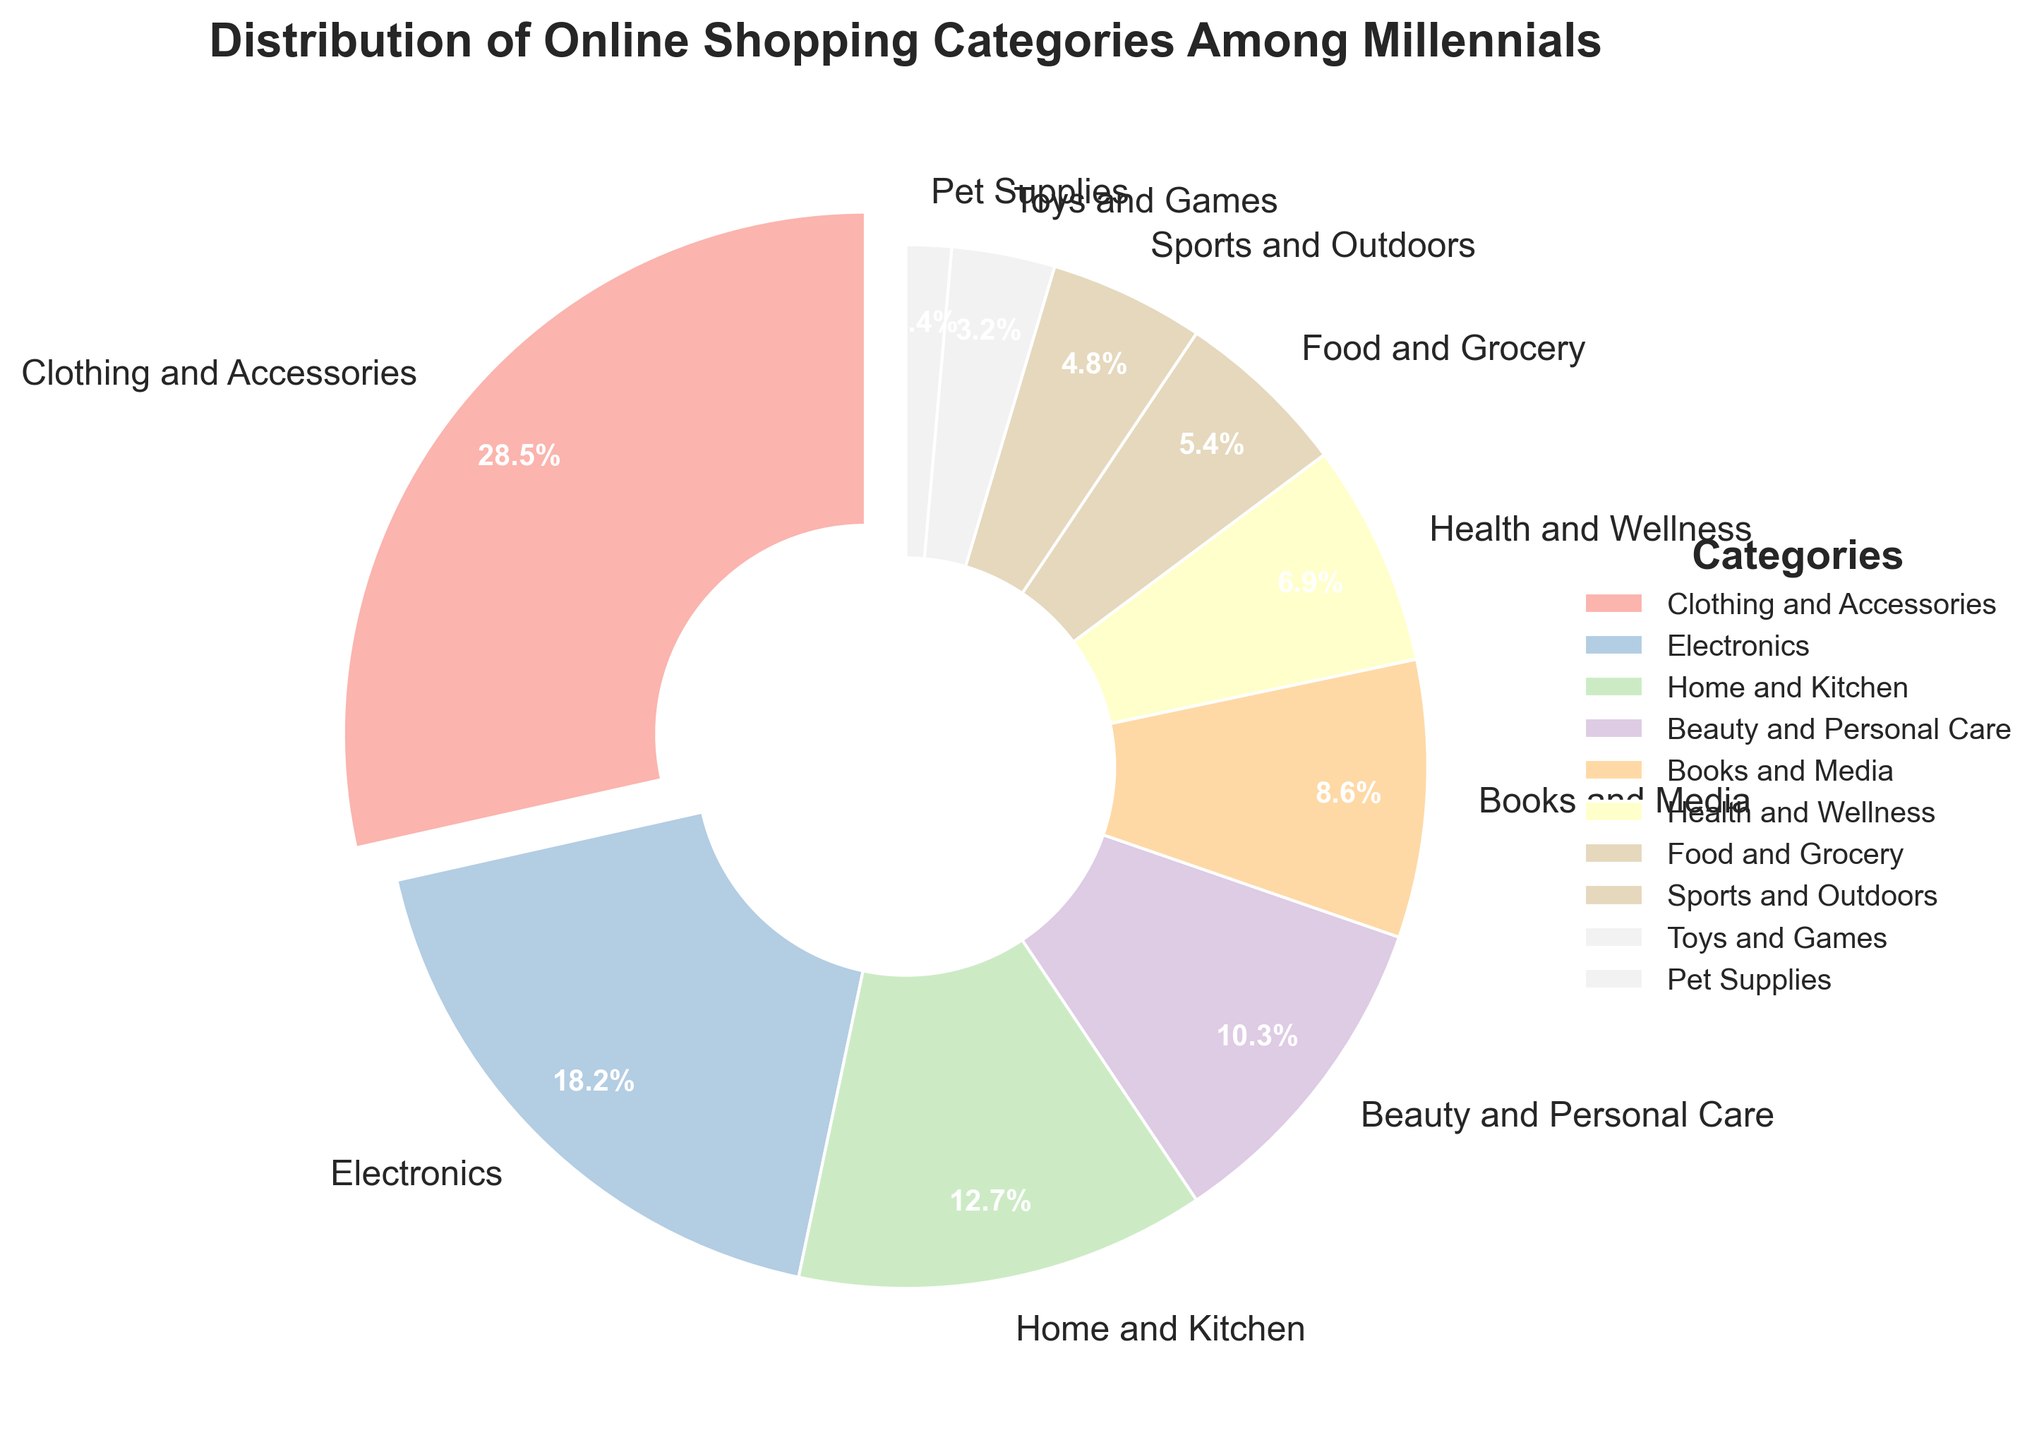What percentage of millennials' online shopping is dedicated to Clothing and Accessories? The pie chart shows the percentage of different categories for millennials' online shopping. By looking at the "Clothing and Accessories" segment, we can see that it accounts for 28.5%.
Answer: 28.5% Which category has the smallest percentage of online shopping among millennials? By examining the segments of the pie chart, we can see that the "Pet Supplies" segment is the smallest, indicating it has the smallest percentage. The percentage for Pet Supplies is 1.4%.
Answer: Pet Supplies How much more percentage do millennials spend on Electronics compared to Food and Grocery? The percentage for Electronics is 18.2%, and for Food and Grocery, it is 5.4%. Subtract the percentage of Food and Grocery from Electronics: 18.2% - 5.4% = 12.8%.
Answer: 12.8% Which categories make up more than 10% of the total online shopping distribution among millennials? By examining the pie chart, we can identify the segments that are larger than 10%. These include Clothing and Accessories (28.5%), Electronics (18.2%), Home and Kitchen (12.7%), and Beauty and Personal Care (10.3%).
Answer: Clothing and Accessories, Electronics, Home and Kitchen, Beauty and Personal Care What is the combined percentage for Books and Media, Health and Wellness, and Sports and Outdoors categories? The percentages for Books and Media, Health and Wellness, and Sports and Outdoors are 8.6%, 6.9%, and 4.8% respectively. Adding these together: 8.6% + 6.9% + 4.8% = 20.3%.
Answer: 20.3% Which two categories have the closest percentages, and what are their values? By examining the pie chart, we can identify that Home and Kitchen (12.7%) and Beauty and Personal Care (10.3%) have the closest percentages.
Answer: Home and Kitchen (12.7%) and Beauty and Personal Care (10.3%) What is the percentage difference between the largest and smallest categories? The largest category is Clothing and Accessories (28.5%), and the smallest is Pet Supplies (1.4%). Subtract the smallest from the largest: 28.5% - 1.4% = 27.1%.
Answer: 27.1% What is the total percentage for categories that are below 10%? Categories below 10% are Books and Media (8.6%), Health and Wellness (6.9%), Food and Grocery (5.4%), Sports and Outdoors (4.8%), Toys and Games (3.2%), and Pet Supplies (1.4%). Adding these together: 8.6% + 6.9% + 5.4% + 4.8% + 3.2% + 1.4% = 30.3%.
Answer: 30.3% How does the size of the Home and Kitchen segment compare visually to the Toys and Games segment? Observing the pie chart, the Home and Kitchen segment is visually larger than the Toys and Games segment. The Home and Kitchen (12.7%) is more than three times the percentage of Toys and Games (3.2%).
Answer: Home and Kitchen is larger 